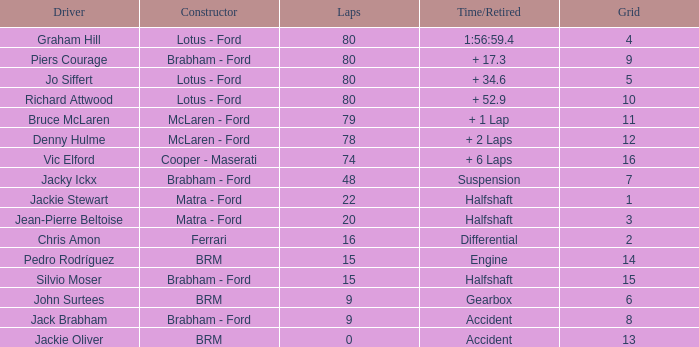What is the time/retired for brm with a grid of 13? Accident. 